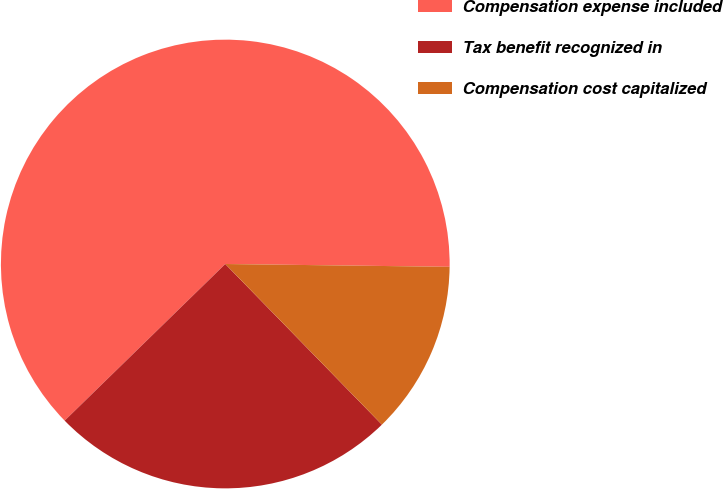<chart> <loc_0><loc_0><loc_500><loc_500><pie_chart><fcel>Compensation expense included<fcel>Tax benefit recognized in<fcel>Compensation cost capitalized<nl><fcel>62.5%<fcel>25.0%<fcel>12.5%<nl></chart> 